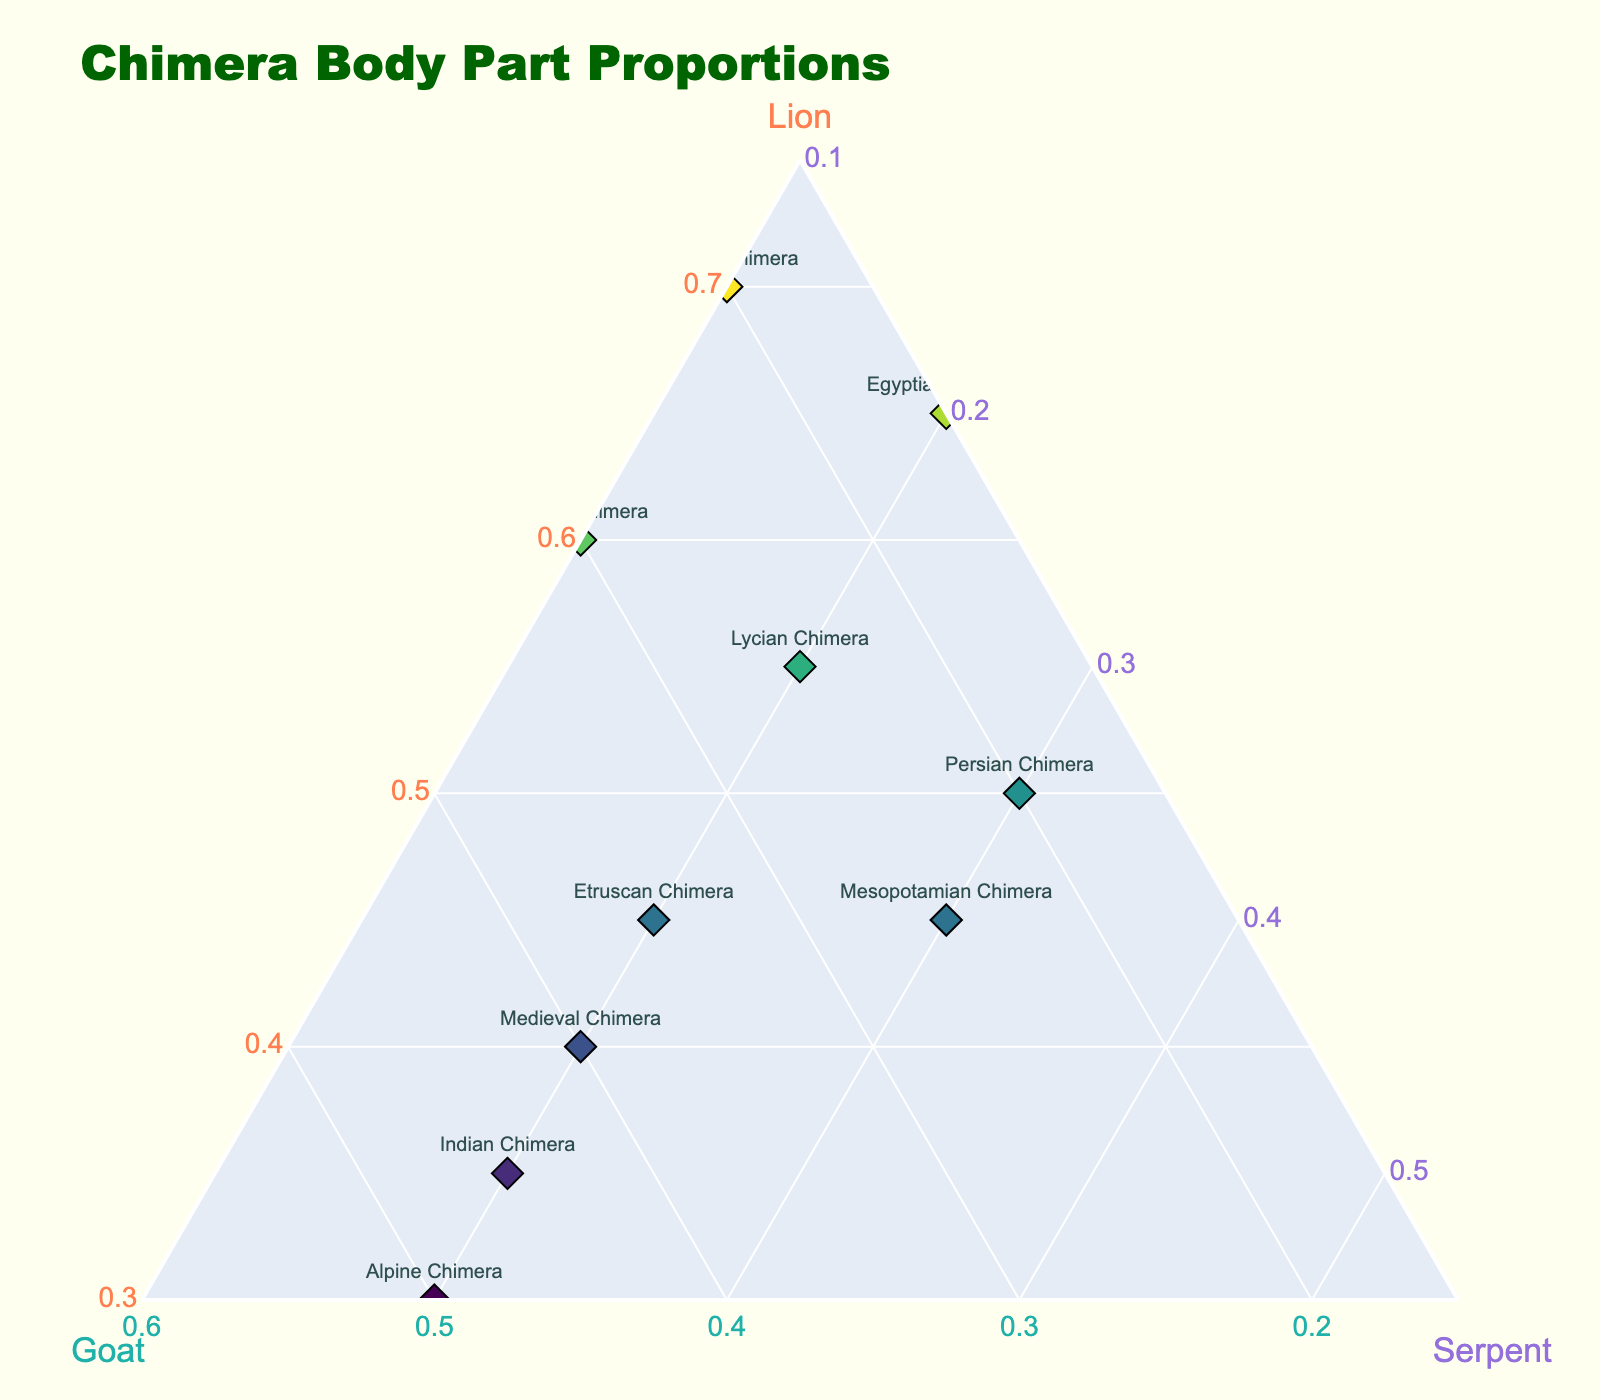What is the title of the plot? If you look at the top of the plot, the title is prominently displayed in a larger font size.
Answer: Chimera Body Part Proportions Which axis represents the proportion of the serpent body part? The c-axis, typically the one labeled as 'c' on ternary plots, is titled "Serpent."
Answer: The c-axis How many specimens have a higher proportion of lion parts than goat parts? Count the specimens where the lion (a-axis) component is higher than the goat (b-axis) component.
Answer: Seven specimens Which chimera has the highest proportion of lion parts? Look for the point highest on the a-axis (Lion) and find its label.
Answer: African Chimera What is the smallest proportion of goat parts among the specimens? Identify the smallest value on the b-axis (Goat) by examining points' positions relative to the Goat axis title.
Answer: 15% (Egyptian Chimera) What is the average proportion of lion parts across all specimens? Sum all the lion proportions and divide by the number of specimens; (60+45+55+40+50+35+70+30+45+65)/10.
Answer: 49.5% Which chimera has equal proportions of goat and serpent body parts? Find the point where the b-axis and c-axis values are equal by examining the plotted points.
Answer: Medieval Chimera Which specimens have a larger proportion of serpent parts than lion parts? Identify points where the c-axis value (Serpent) is greater than the a-axis (Lion) value.
Answer: Alpine Chimera, Mesopotamian Chimera, Persian Chimera Which two chimeras have the closest proportions of lion parts? Determine the pair with the smallest difference between their lion proportions by comparing numbers.
Answer: Greek Chimera and Lycian Chimera 